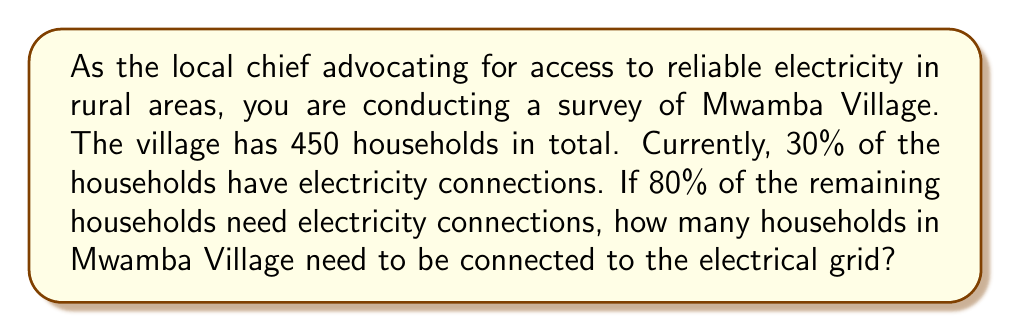Provide a solution to this math problem. Let's break this problem down step-by-step:

1. Calculate the number of households that already have electricity:
   $$ 30\% \text{ of } 450 = 0.30 \times 450 = 135 \text{ households} $$

2. Calculate the number of households without electricity:
   $$ 450 - 135 = 315 \text{ households} $$

3. Calculate 80% of the households without electricity:
   $$ 80\% \text{ of } 315 = 0.80 \times 315 = 252 \text{ households} $$

Therefore, 252 households in Mwamba Village need to be connected to the electrical grid.
Answer: 252 households 